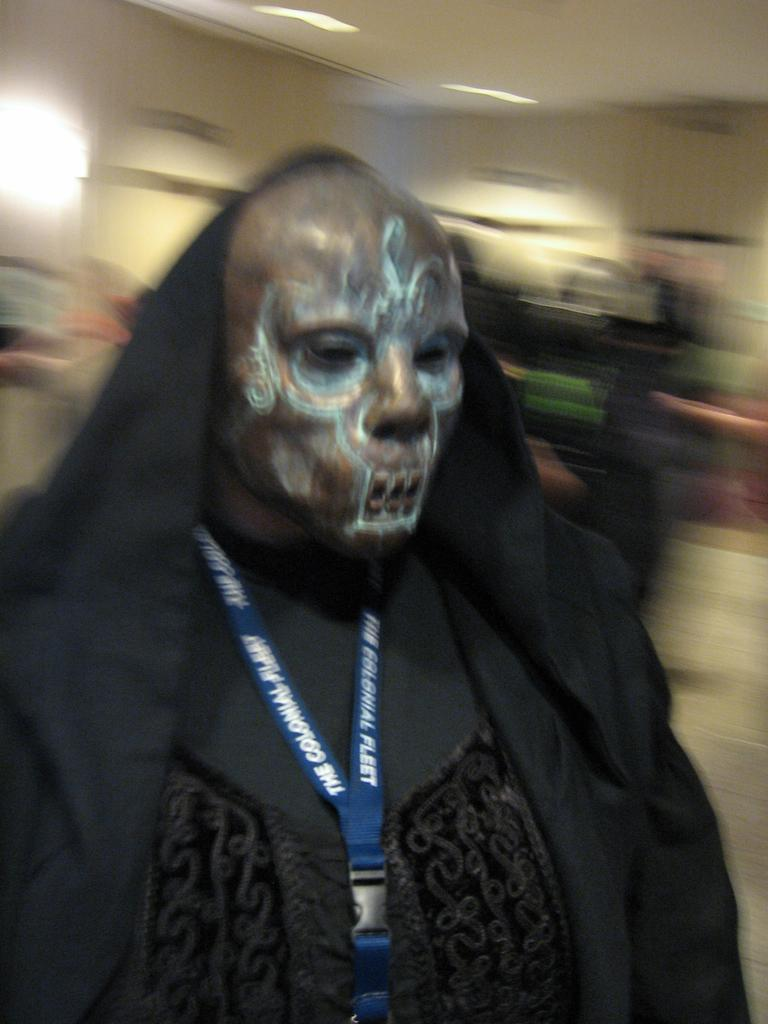What is the main subject of the image? There is a person in the image. What is the person wearing in the image? The person is wearing a costume and a mask on their face. What additional item can be seen in the image? There is an ID card present in the image. How would you describe the background of the image? The background of the image is blurry. Can you see a baby holding a spoon near the mailbox in the image? There is no baby, spoon, or mailbox present in the image. 